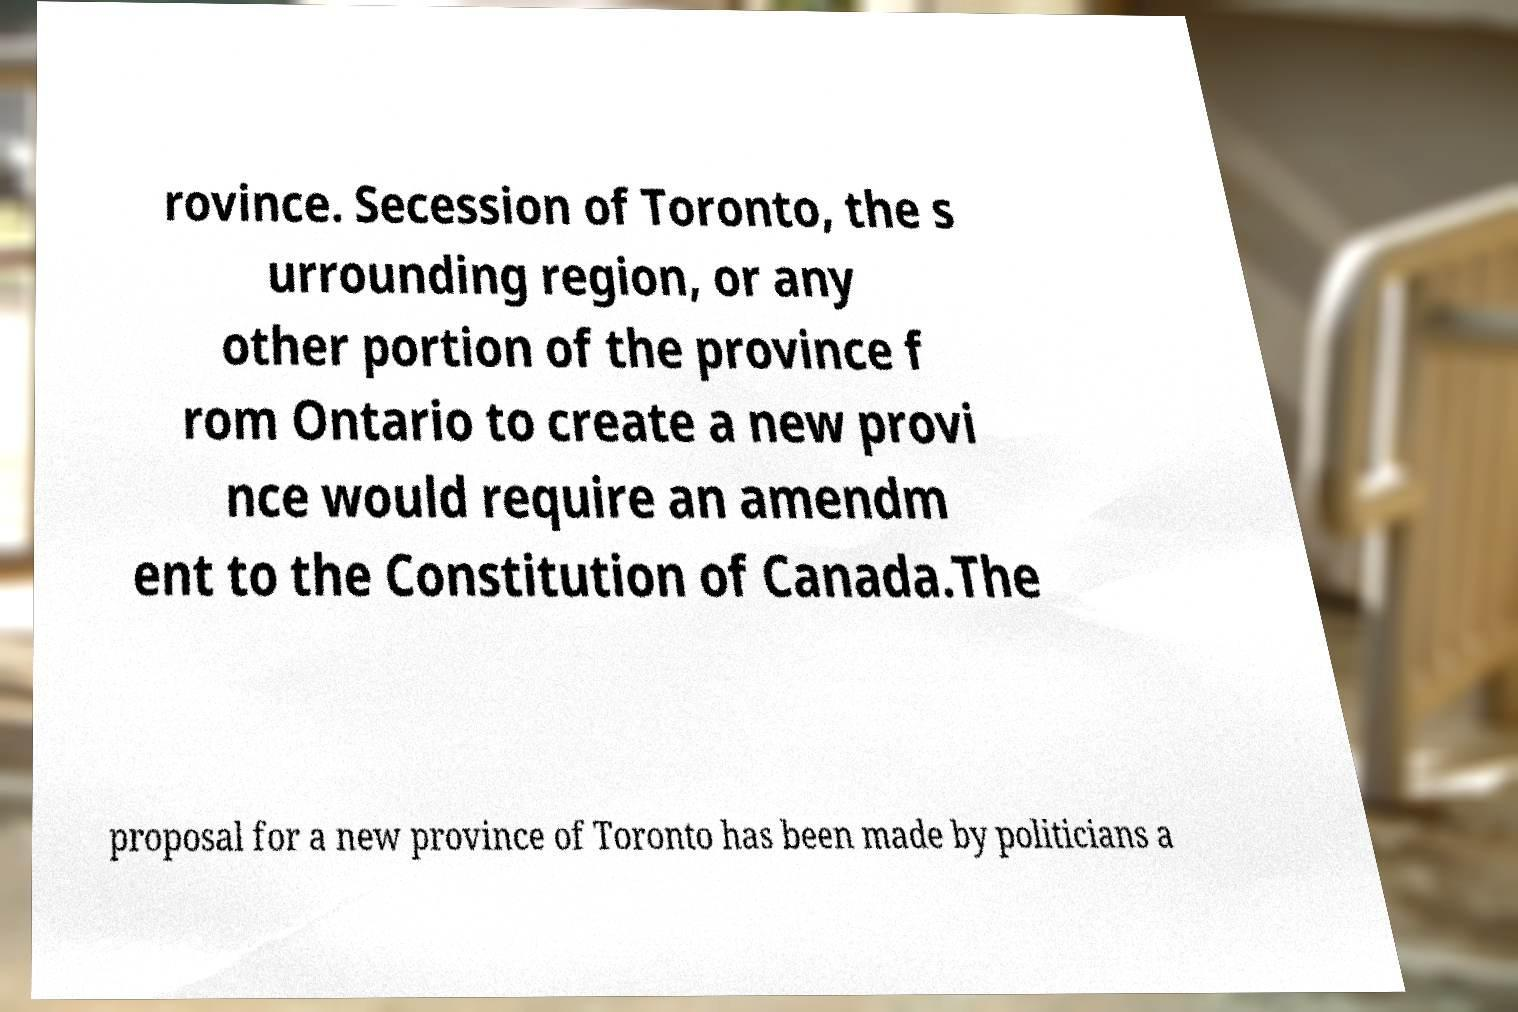What messages or text are displayed in this image? I need them in a readable, typed format. rovince. Secession of Toronto, the s urrounding region, or any other portion of the province f rom Ontario to create a new provi nce would require an amendm ent to the Constitution of Canada.The proposal for a new province of Toronto has been made by politicians a 